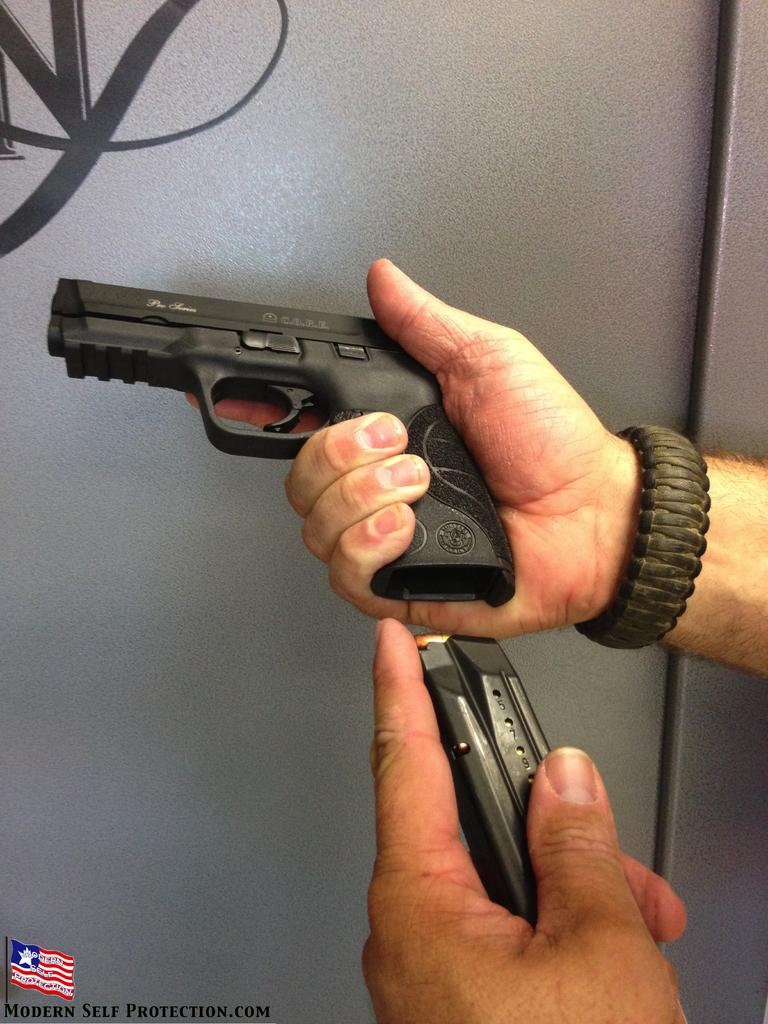What is the person in the image holding? The person is holding a handgun in the image. What else can be seen related to the handgun? There are bullets visible in the image. What is on the wall in the image? There is a wall with a logo in the image. Is there any additional information about the image itself? Yes, there is a watermark on the image. What type of vest is the person wearing in the image? There is no vest visible in the image; the person is holding a handgun and there are bullets present. What kind of produce can be seen in the image? There is no produce present in the image. 